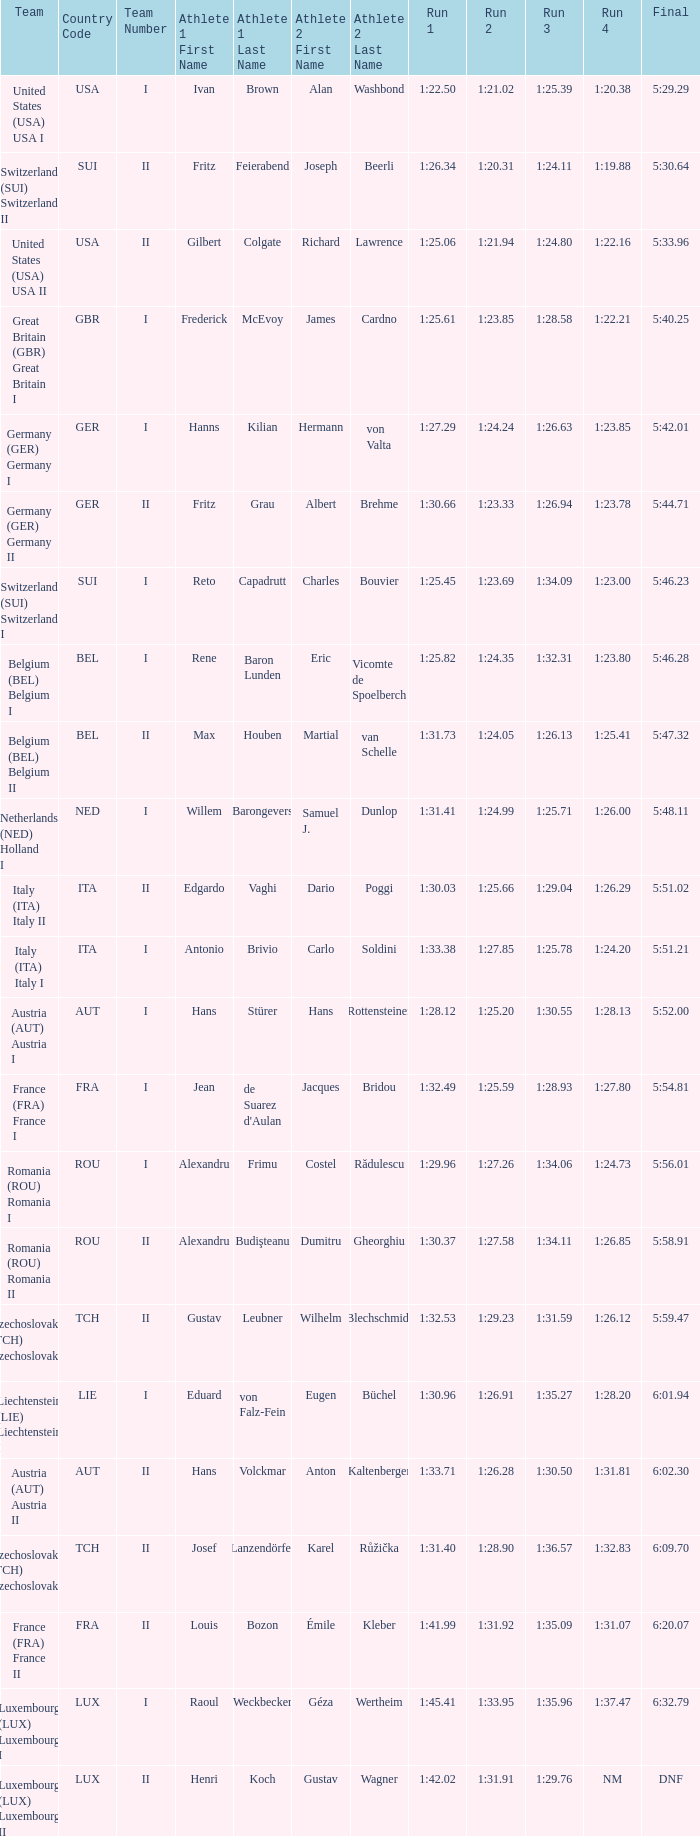Which Run 2 has a Run 1 of 1:30.03? 1:25.66. 